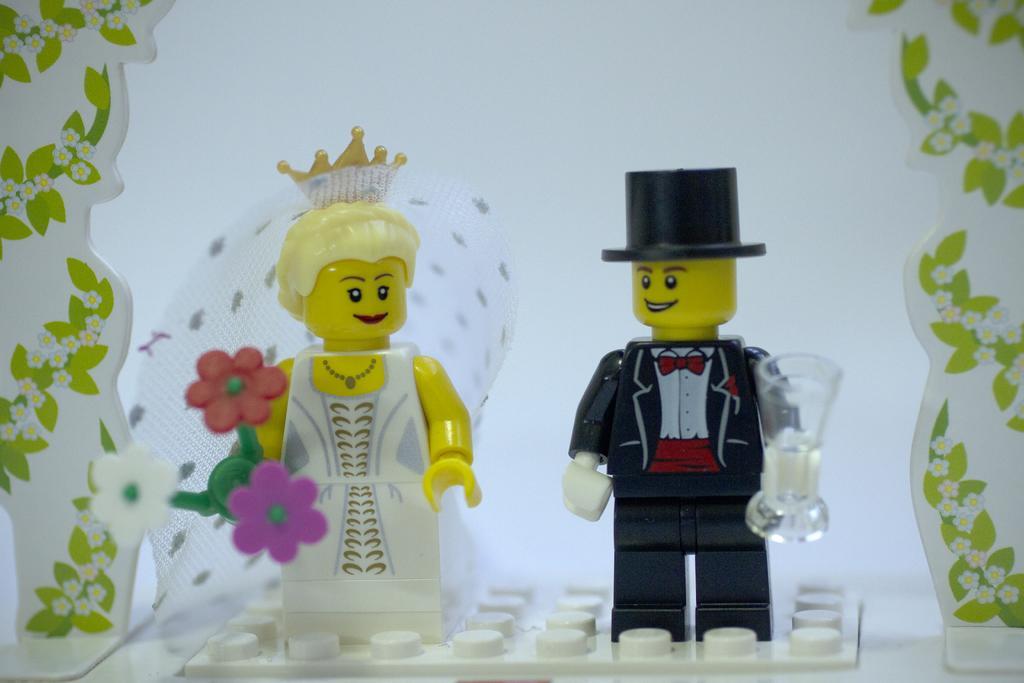In one or two sentences, can you explain what this image depicts? In this image we can see some toys which are placed on the surface. 